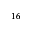Convert formula to latex. <formula><loc_0><loc_0><loc_500><loc_500>^ { 1 6 }</formula> 